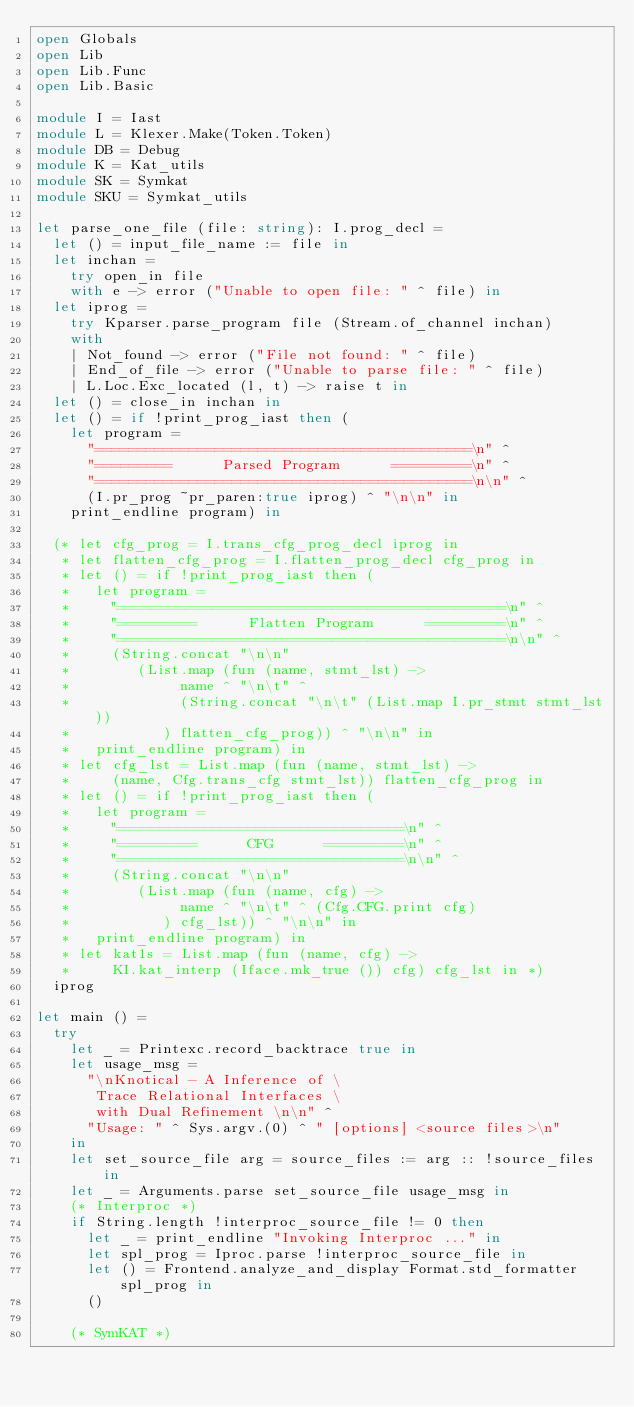Convert code to text. <code><loc_0><loc_0><loc_500><loc_500><_OCaml_>open Globals
open Lib
open Lib.Func
open Lib.Basic

module I = Iast
module L = Klexer.Make(Token.Token)
module DB = Debug
module K = Kat_utils
module SK = Symkat
module SKU = Symkat_utils

let parse_one_file (file: string): I.prog_decl =
  let () = input_file_name := file in
  let inchan =
    try open_in file
    with e -> error ("Unable to open file: " ^ file) in
  let iprog =
    try Kparser.parse_program file (Stream.of_channel inchan)
    with
    | Not_found -> error ("File not found: " ^ file)
    | End_of_file -> error ("Unable to parse file: " ^ file)
    | L.Loc.Exc_located (l, t) -> raise t in
  let () = close_in inchan in
  let () = if !print_prog_iast then (
    let program =
      "============================================\n" ^
      "=========      Parsed Program      =========\n" ^
      "============================================\n\n" ^
      (I.pr_prog ~pr_paren:true iprog) ^ "\n\n" in
    print_endline program) in

  (* let cfg_prog = I.trans_cfg_prog_decl iprog in
   * let flatten_cfg_prog = I.flatten_prog_decl cfg_prog in
   * let () = if !print_prog_iast then (
   *   let program =
   *     "=============================================\n" ^
   *     "=========      Flatten Program      =========\n" ^
   *     "=============================================\n\n" ^
   *     (String.concat "\n\n"
   *        (List.map (fun (name, stmt_lst) ->
   *             name ^ "\n\t" ^
   *             (String.concat "\n\t" (List.map I.pr_stmt stmt_lst))
   *           ) flatten_cfg_prog)) ^ "\n\n" in
   *   print_endline program) in
   * let cfg_lst = List.map (fun (name, stmt_lst) ->
   *     (name, Cfg.trans_cfg stmt_lst)) flatten_cfg_prog in
   * let () = if !print_prog_iast then (
   *   let program =
   *     "=================================\n" ^
   *     "=========      CFG      =========\n" ^
   *     "=================================\n\n" ^
   *     (String.concat "\n\n"
   *        (List.map (fun (name, cfg) ->
   *             name ^ "\n\t" ^ (Cfg.CFG.print cfg)
   *           ) cfg_lst)) ^ "\n\n" in
   *   print_endline program) in
   * let kat1s = List.map (fun (name, cfg) ->
   *     KI.kat_interp (Iface.mk_true ()) cfg) cfg_lst in *)
  iprog

let main () =
  try
    let _ = Printexc.record_backtrace true in
    let usage_msg =
      "\nKnotical - A Inference of \
       Trace Relational Interfaces \
       with Dual Refinement \n\n" ^
      "Usage: " ^ Sys.argv.(0) ^ " [options] <source files>\n"
    in
    let set_source_file arg = source_files := arg :: !source_files in
    let _ = Arguments.parse set_source_file usage_msg in
    (* Interproc *)
    if String.length !interproc_source_file != 0 then
      let _ = print_endline "Invoking Interproc ..." in
      let spl_prog = Iproc.parse !interproc_source_file in
      let () = Frontend.analyze_and_display Format.std_formatter spl_prog in
      ()

    (* SymKAT *)</code> 